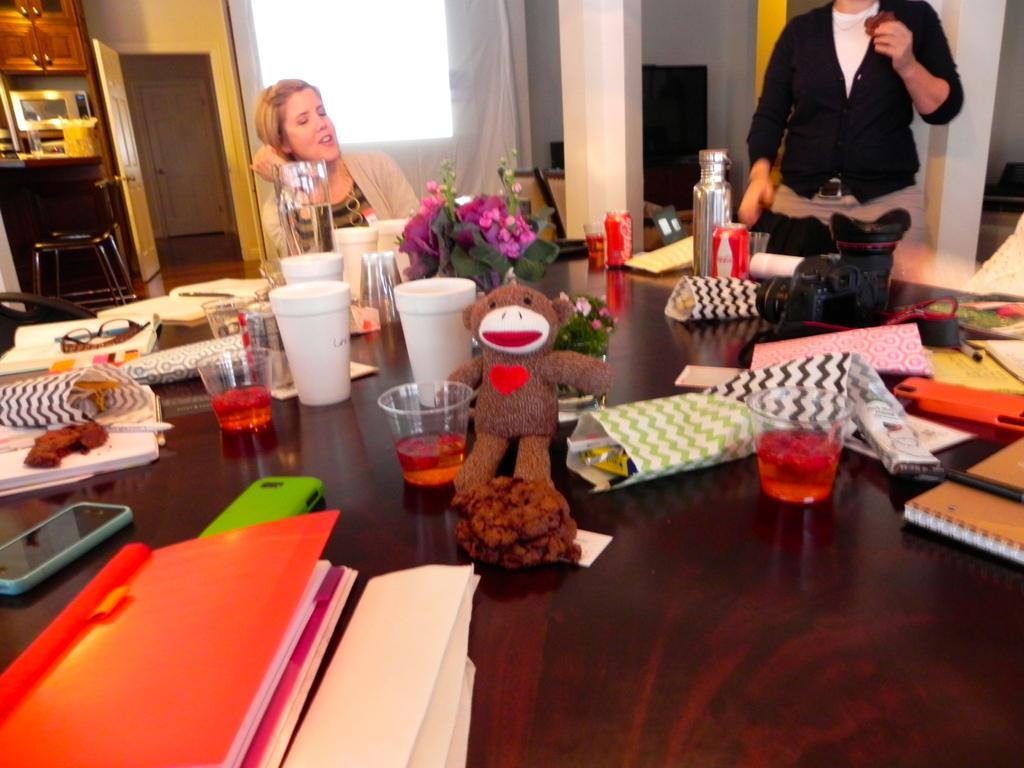Please provide a concise description of this image. In the left top a woman is sitting on the chair in front of the table. In the right a person is standing. On the table glass, books, mobiles, color sheets, doll, flower vase, specs and bottle is kept. In the left top a door is visible and window is visible on which curtain is there. And walls are white in color. In the left chair and cupboard is visible. This image is taken inside a room. 